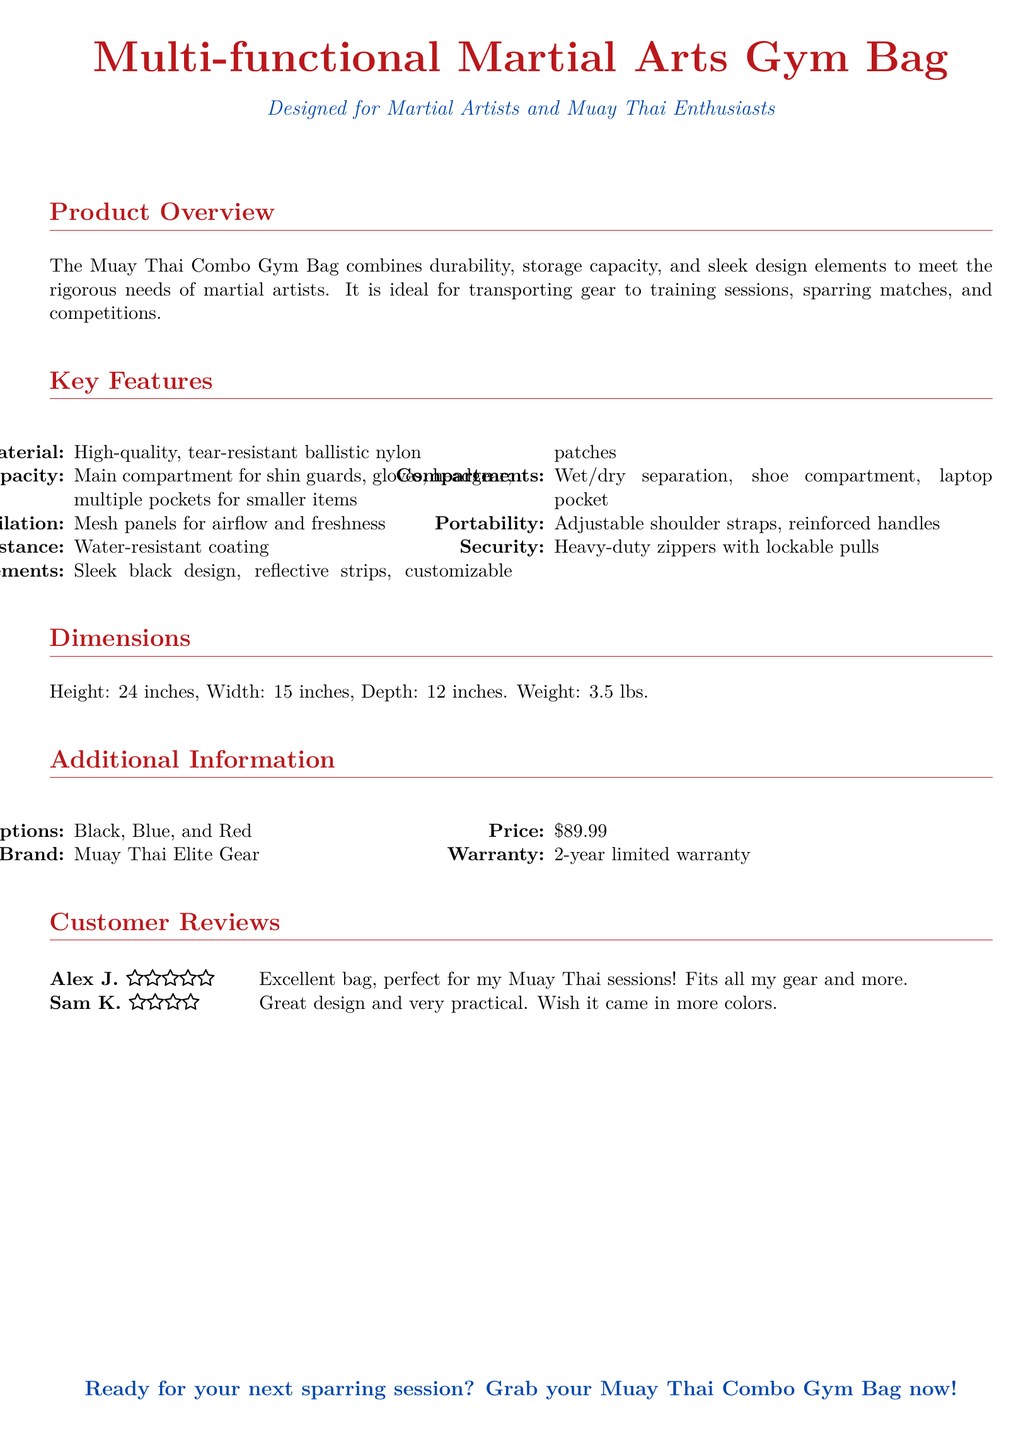What material is used for the gym bag? The document states that the gym bag is made of high-quality, tear-resistant ballistic nylon.
Answer: ballistic nylon What is the storage capacity of the gym bag? The storage capacity includes a main compartment for shin guards, gloves, and headgear, along with multiple pockets for smaller items.
Answer: main compartment for shin guards, gloves, headgear; multiple pockets What is the weight of the Muay Thai Combo Gym Bag? The weight is specified under the dimensions section, which indicates the bag weighs 3.5 lbs.
Answer: 3.5 lbs How many color options are available for the bag? The document lists three available color options: Black, Blue, and Red.
Answer: 3 What feature enhances airflow in the bag? The ventilation feature of the bag is highlighted as having mesh panels for airflow and freshness.
Answer: mesh panels What is the warranty period for the bag? The warranty information indicates a 2-year limited warranty for the product.
Answer: 2-year limited warranty What price is listed for the gym bag? The price of the bag is mentioned in the additional information section, which states it's $89.99.
Answer: $89.99 Which brand manufactures the Muay Thai Combo Gym Bag? The brand name is specified in the additional information section, which identifies it as Muay Thai Elite Gear.
Answer: Muay Thai Elite Gear What design features are included on the bag? The document notes design elements like a sleek black design, reflective strips, and customizable patches.
Answer: sleek black design, reflective strips, customizable patches 